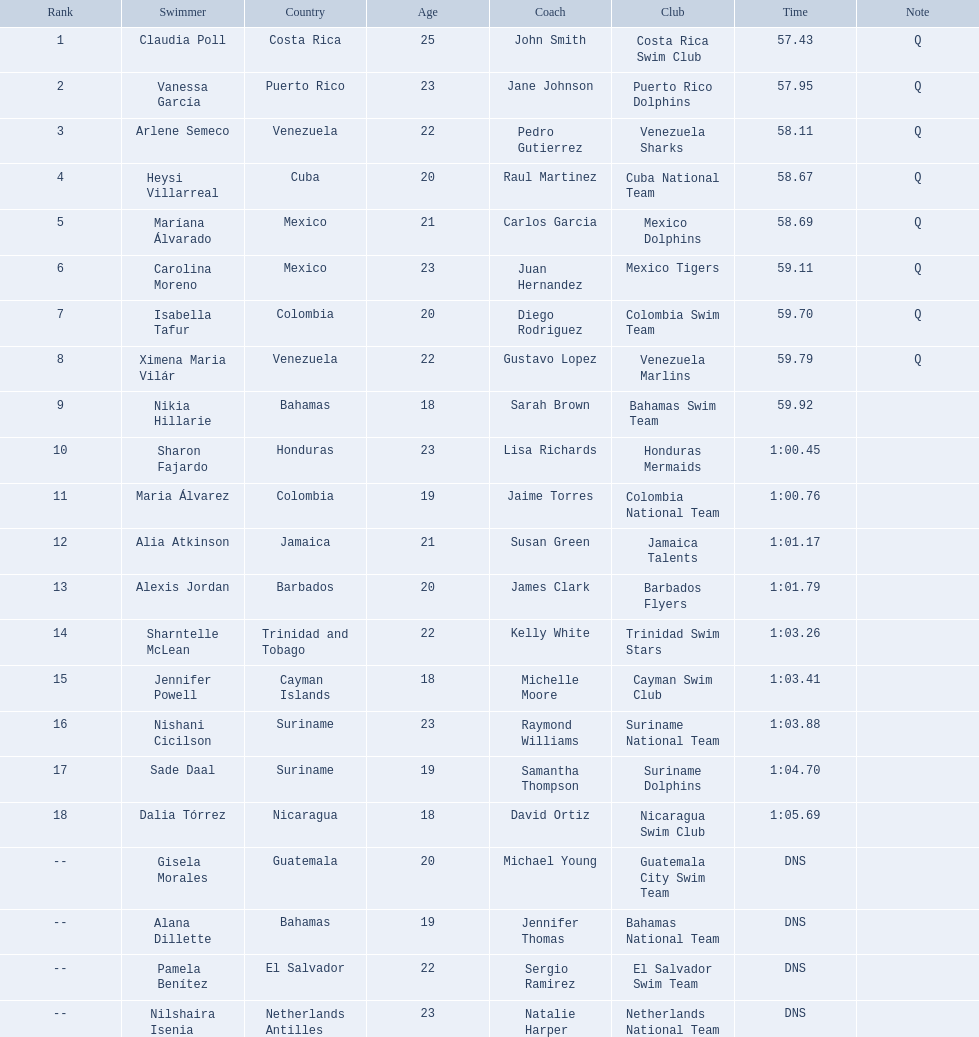Who were all of the swimmers in the women's 100 metre freestyle? Claudia Poll, Vanessa García, Arlene Semeco, Heysi Villarreal, Maríana Álvarado, Carolina Moreno, Isabella Tafur, Ximena Maria Vilár, Nikia Hillarie, Sharon Fajardo, Maria Álvarez, Alia Atkinson, Alexis Jordan, Sharntelle McLean, Jennifer Powell, Nishani Cicilson, Sade Daal, Dalia Tórrez, Gisela Morales, Alana Dillette, Pamela Benítez, Nilshaira Isenia. Where was each swimmer from? Costa Rica, Puerto Rico, Venezuela, Cuba, Mexico, Mexico, Colombia, Venezuela, Bahamas, Honduras, Colombia, Jamaica, Barbados, Trinidad and Tobago, Cayman Islands, Suriname, Suriname, Nicaragua, Guatemala, Bahamas, El Salvador, Netherlands Antilles. What were their ranks? 1, 2, 3, 4, 5, 6, 7, 8, 9, 10, 11, 12, 13, 14, 15, 16, 17, 18, --, --, --, --. Who was in the top eight? Claudia Poll, Vanessa García, Arlene Semeco, Heysi Villarreal, Maríana Álvarado, Carolina Moreno, Isabella Tafur, Ximena Maria Vilár. Of those swimmers, which one was from cuba? Heysi Villarreal. 